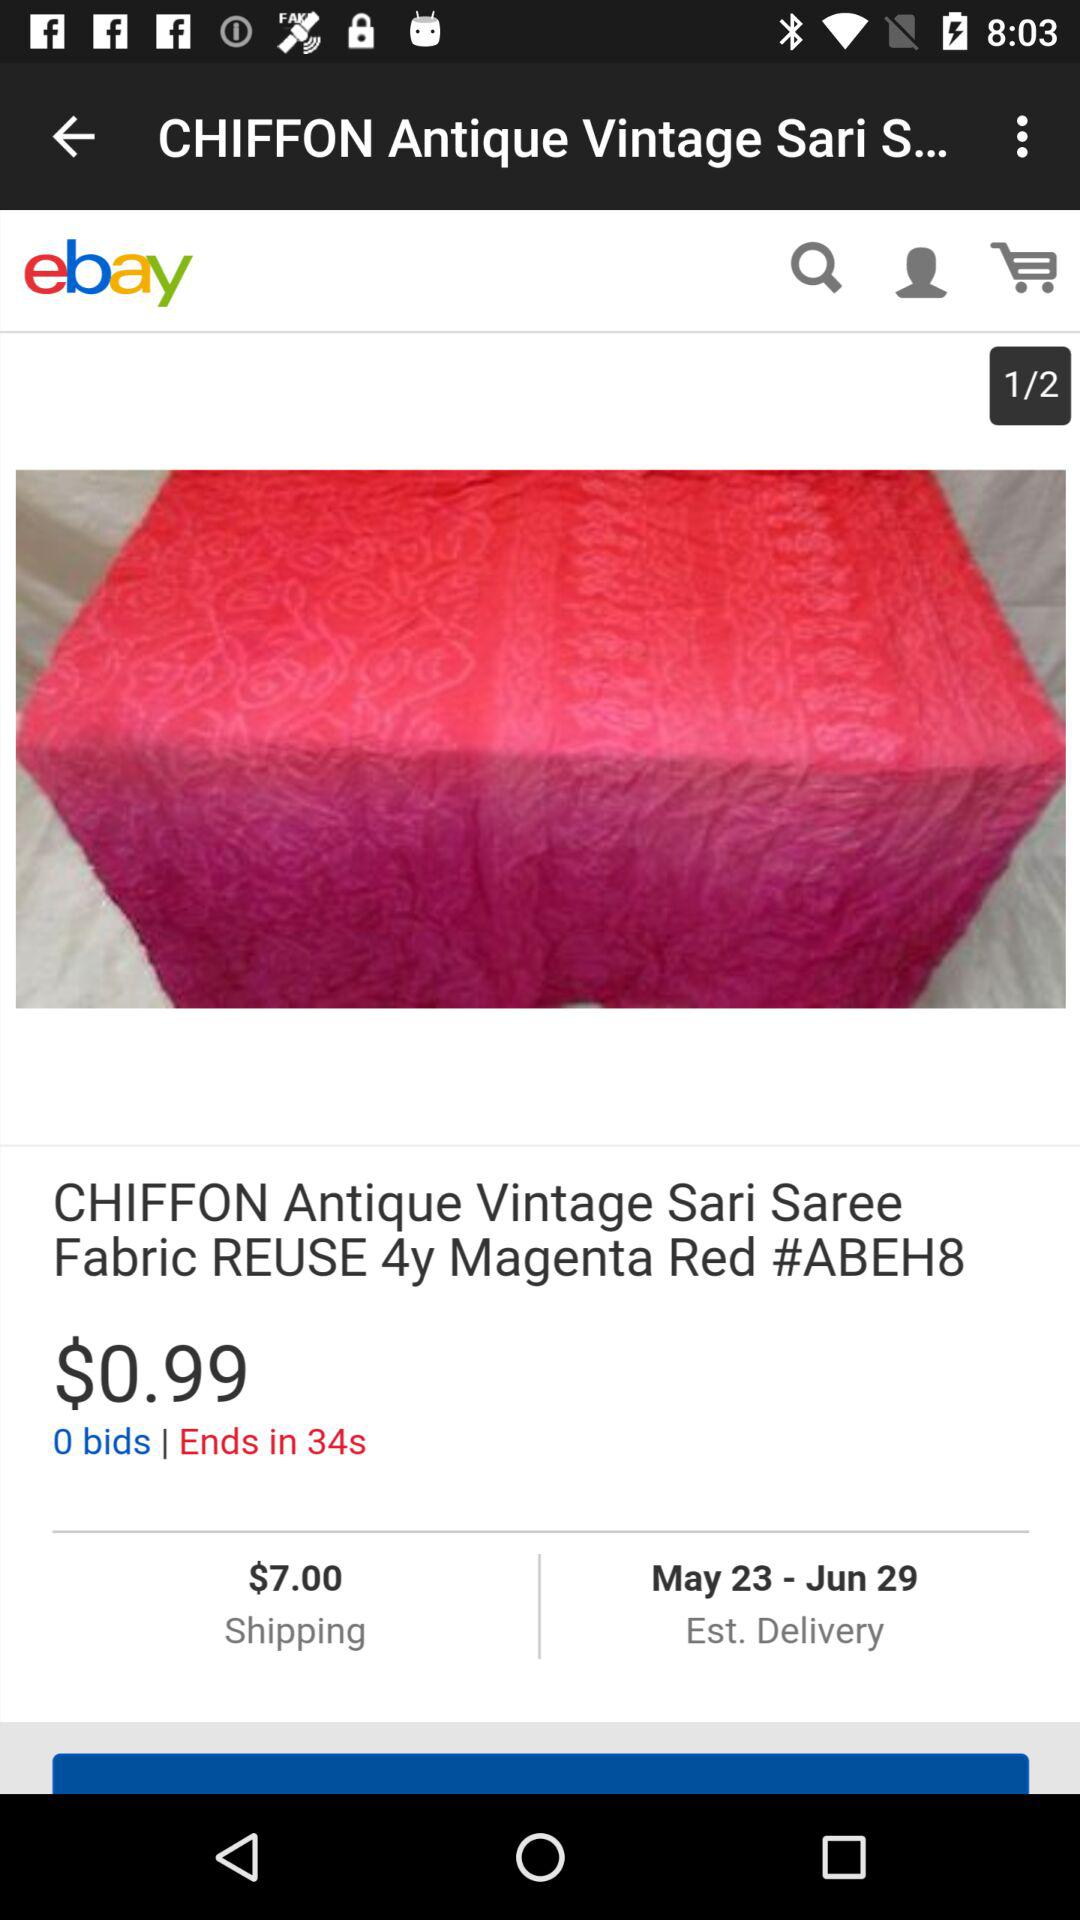What is the colour of the saree? The saree colour is "Magenta Red". 